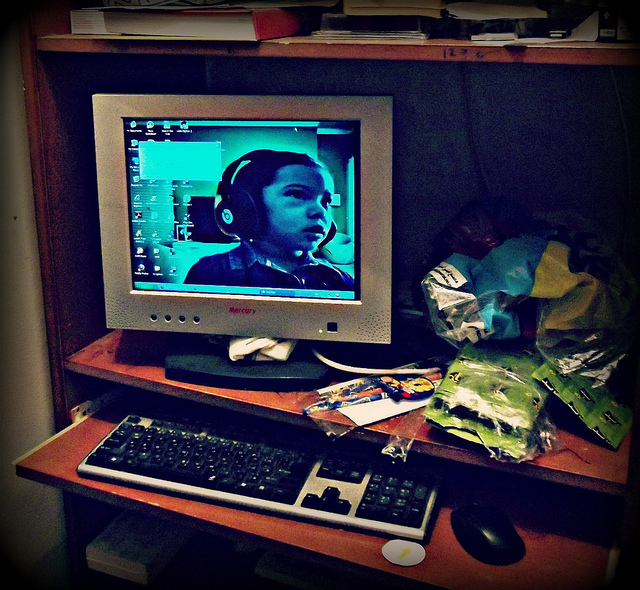<image>What color is the laptop? I am not sure about the color of the laptop. It can be seen as black, white or silver. What color is the laptop? The laptop is silver in color. 